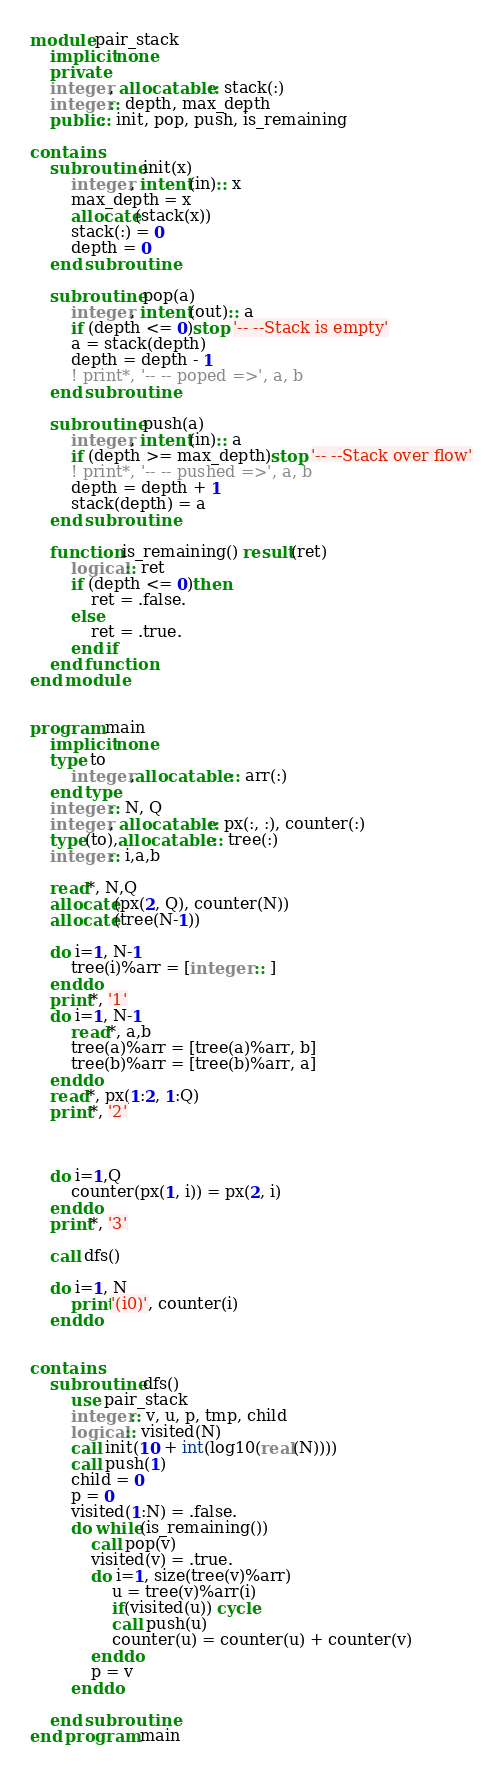<code> <loc_0><loc_0><loc_500><loc_500><_FORTRAN_>module pair_stack
    implicit none
    private
    integer, allocatable:: stack(:)
    integer:: depth, max_depth
    public:: init, pop, push, is_remaining

contains
    subroutine init(x)
        integer, intent(in):: x
        max_depth = x
        allocate(stack(x))
        stack(:) = 0
        depth = 0
    end subroutine

    subroutine pop(a)
        integer, intent(out):: a
        if (depth <= 0)stop '-- --Stack is empty'
        a = stack(depth)
        depth = depth - 1
        ! print*, '-- -- poped =>', a, b
    end subroutine

    subroutine push(a)
        integer, intent(in):: a
        if (depth >= max_depth)stop '-- --Stack over flow'
        ! print*, '-- -- pushed =>', a, b
        depth = depth + 1
        stack(depth) = a
    end subroutine

    function is_remaining() result(ret)
        logical:: ret
        if (depth <= 0)then
            ret = .false.
        else
            ret = .true.
        end if
    end function
end module


program main
    implicit none
    type to
        integer,allocatable :: arr(:)
    end type
    integer:: N, Q
    integer, allocatable:: px(:, :), counter(:)
    type(to),allocatable :: tree(:)
    integer:: i,a,b

    read*, N,Q
    allocate(px(2, Q), counter(N))
    allocate(tree(N-1))

    do i=1, N-1
        tree(i)%arr = [integer :: ]
    enddo
    print*, '1'
    do i=1, N-1
        read*, a,b
        tree(a)%arr = [tree(a)%arr, b]
        tree(b)%arr = [tree(b)%arr, a]
    enddo
    read*, px(1:2, 1:Q)
    print*, '2'

    

    do i=1,Q
        counter(px(1, i)) = px(2, i)
    enddo
    print*, '3'

    call dfs()
    
    do i=1, N
        print'(i0)', counter(i)
    enddo


contains
    subroutine dfs()
        use pair_stack
        integer:: v, u, p, tmp, child
        logical:: visited(N)
        call init(10 + int(log10(real(N))))
        call push(1)
        child = 0
        p = 0
        visited(1:N) = .false.
        do while(is_remaining())
            call pop(v)
            visited(v) = .true.
            do i=1, size(tree(v)%arr)
                u = tree(v)%arr(i)
                if(visited(u)) cycle
                call push(u)
                counter(u) = counter(u) + counter(v)
            enddo
            p = v
        enddo

    end subroutine
end program main</code> 